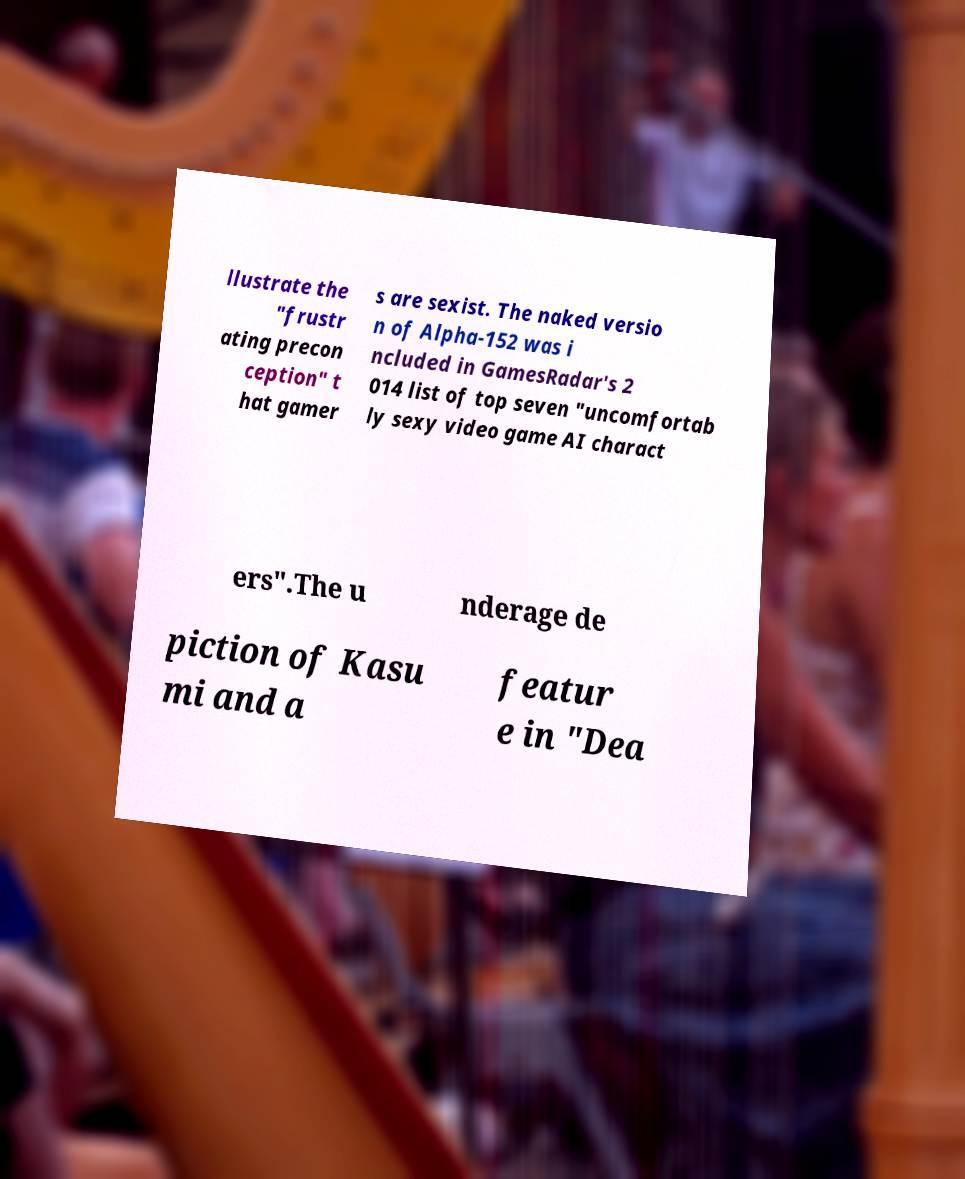Could you extract and type out the text from this image? llustrate the "frustr ating precon ception" t hat gamer s are sexist. The naked versio n of Alpha-152 was i ncluded in GamesRadar's 2 014 list of top seven "uncomfortab ly sexy video game AI charact ers".The u nderage de piction of Kasu mi and a featur e in "Dea 